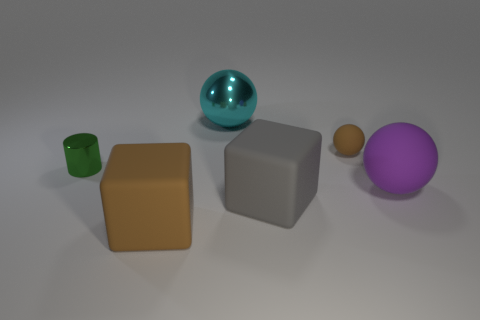What is the shape of the cyan object that is the same material as the tiny cylinder?
Your response must be concise. Sphere. What is the material of the brown object left of the gray thing?
Offer a very short reply. Rubber. Is the size of the ball in front of the small brown object the same as the brown thing left of the big metal thing?
Offer a terse response. Yes. The small rubber thing is what color?
Make the answer very short. Brown. There is a green object to the left of the metallic ball; is it the same shape as the big purple object?
Your answer should be compact. No. What is the brown sphere made of?
Your response must be concise. Rubber. The brown object that is the same size as the metal ball is what shape?
Ensure brevity in your answer.  Cube. Is there a big rubber block that has the same color as the tiny ball?
Ensure brevity in your answer.  Yes. There is a tiny matte thing; does it have the same color as the large rubber object on the left side of the big cyan ball?
Ensure brevity in your answer.  Yes. What is the color of the big cube that is on the left side of the big block on the right side of the big metal thing?
Give a very brief answer. Brown. 